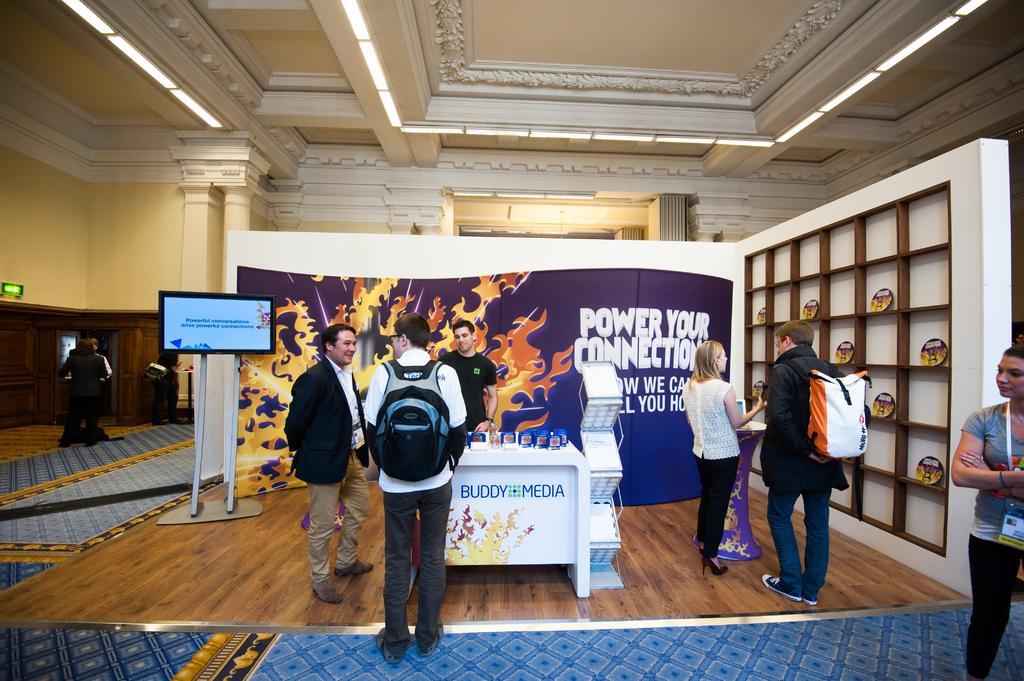Please provide a concise description of this image. In this picture there are group of people standing and here are objects on the table and in the cupboard. There is a screen and there is text on the screen and on the hoarding. At the top there are lights. At the bottom there is a floor and there is a mat. On the left side of the image it looks like a door. 